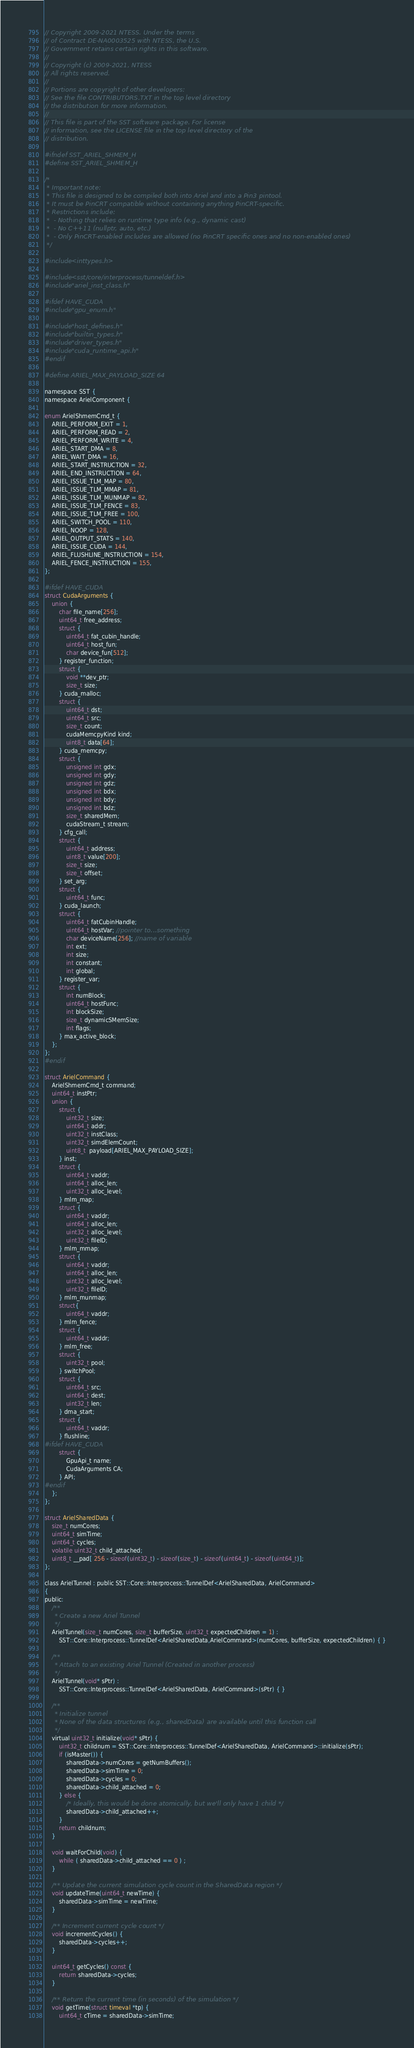<code> <loc_0><loc_0><loc_500><loc_500><_C_>// Copyright 2009-2021 NTESS. Under the terms
// of Contract DE-NA0003525 with NTESS, the U.S.
// Government retains certain rights in this software.
//
// Copyright (c) 2009-2021, NTESS
// All rights reserved.
//
// Portions are copyright of other developers:
// See the file CONTRIBUTORS.TXT in the top level directory
// the distribution for more information.
//
// This file is part of the SST software package. For license
// information, see the LICENSE file in the top level directory of the
// distribution.

#ifndef SST_ARIEL_SHMEM_H
#define SST_ARIEL_SHMEM_H

/*
 * Important note:
 * This file is designed to be compiled both into Ariel and into a Pin3 pintool.
 * It must be PinCRT compatible without containing anything PinCRT-specific.
 * Restrictions include:
 *  - Nothing that relies on runtime type info (e.g., dynamic cast)
 *  - No C++11 (nullptr, auto, etc.)
 *  - Only PinCRT-enabled includes are allowed (no PinCRT specific ones and no non-enabled ones)
 */

#include <inttypes.h>

#include <sst/core/interprocess/tunneldef.h>
#include "ariel_inst_class.h"

#ifdef HAVE_CUDA
#include "gpu_enum.h"

#include "host_defines.h"
#include "builtin_types.h"
#include "driver_types.h"
#include "cuda_runtime_api.h"
#endif

#define ARIEL_MAX_PAYLOAD_SIZE 64

namespace SST {
namespace ArielComponent {

enum ArielShmemCmd_t {
    ARIEL_PERFORM_EXIT = 1,
    ARIEL_PERFORM_READ = 2,
    ARIEL_PERFORM_WRITE = 4,
    ARIEL_START_DMA = 8,
    ARIEL_WAIT_DMA = 16,
    ARIEL_START_INSTRUCTION = 32,
    ARIEL_END_INSTRUCTION = 64,
    ARIEL_ISSUE_TLM_MAP = 80,
    ARIEL_ISSUE_TLM_MMAP = 81,
    ARIEL_ISSUE_TLM_MUNMAP = 82,
    ARIEL_ISSUE_TLM_FENCE = 83,
    ARIEL_ISSUE_TLM_FREE = 100,
    ARIEL_SWITCH_POOL = 110,
    ARIEL_NOOP = 128,
    ARIEL_OUTPUT_STATS = 140,
    ARIEL_ISSUE_CUDA = 144,
    ARIEL_FLUSHLINE_INSTRUCTION = 154,
    ARIEL_FENCE_INSTRUCTION = 155,
};

#ifdef HAVE_CUDA
struct CudaArguments {
    union {
        char file_name[256];
        uint64_t free_address;
        struct {
            uint64_t fat_cubin_handle;
            uint64_t host_fun;
            char device_fun[512];
        } register_function;
        struct {
            void **dev_ptr;
            size_t size;
        } cuda_malloc;
        struct {
            uint64_t dst;
            uint64_t src;
            size_t count;
            cudaMemcpyKind kind;
            uint8_t data[64];
        } cuda_memcpy;
        struct {
            unsigned int gdx;
            unsigned int gdy;
            unsigned int gdz;
            unsigned int bdx;
            unsigned int bdy;
            unsigned int bdz;
            size_t sharedMem;
            cudaStream_t stream;
        } cfg_call;
        struct {
            uint64_t address;
            uint8_t value[200];
            size_t size;
            size_t offset;
        } set_arg;
        struct {
            uint64_t func;
        } cuda_launch;
        struct {
            uint64_t fatCubinHandle;
            uint64_t hostVar; //pointer to...something
            char deviceName[256]; //name of variable
            int ext;
            int size;
            int constant;
            int global;
        } register_var;
        struct {
            int numBlock;
            uint64_t hostFunc;
            int blockSize;
            size_t dynamicSMemSize;
            int flags;
        } max_active_block;
    };
};
#endif

struct ArielCommand {
    ArielShmemCmd_t command;
    uint64_t instPtr;
    union {
        struct {
            uint32_t size;
            uint64_t addr;
            uint32_t instClass;
            uint32_t simdElemCount;
            uint8_t  payload[ARIEL_MAX_PAYLOAD_SIZE];
        } inst;
        struct {
            uint64_t vaddr;
            uint64_t alloc_len;
            uint32_t alloc_level;
        } mlm_map;
        struct {
            uint64_t vaddr;
            uint64_t alloc_len;
            uint32_t alloc_level;
            uint32_t fileID;
        } mlm_mmap;
        struct {
            uint64_t vaddr;
            uint64_t alloc_len;
            uint32_t alloc_level;
            uint32_t fileID;
        } mlm_munmap;
        struct{
            uint64_t vaddr;
        } mlm_fence;
        struct {
            uint64_t vaddr;
        } mlm_free;
        struct {
            uint32_t pool;
        } switchPool;
        struct {
            uint64_t src;
            uint64_t dest;
            uint32_t len;
        } dma_start;
        struct {
            uint64_t vaddr;
        } flushline;
#ifdef HAVE_CUDA
        struct {
            GpuApi_t name;
            CudaArguments CA;
        } API;
#endif
    };
};

struct ArielSharedData {
    size_t numCores;
    uint64_t simTime;
    uint64_t cycles;
    volatile uint32_t child_attached;
    uint8_t __pad[ 256 - sizeof(uint32_t) - sizeof(size_t) - sizeof(uint64_t) - sizeof(uint64_t)];
};

class ArielTunnel : public SST::Core::Interprocess::TunnelDef<ArielSharedData, ArielCommand>
{
public:
    /**
     * Create a new Ariel Tunnel
     */
    ArielTunnel(size_t numCores, size_t bufferSize, uint32_t expectedChildren = 1) :
        SST::Core::Interprocess::TunnelDef<ArielSharedData,ArielCommand>(numCores, bufferSize, expectedChildren) { }

    /**
     * Attach to an existing Ariel Tunnel (Created in another process)
     */
    ArielTunnel(void* sPtr) :
        SST::Core::Interprocess::TunnelDef<ArielSharedData, ArielCommand>(sPtr) { }

    /**
     * Initialize tunnel
     * None of the data structures (e.g., sharedData) are available until this function call
     */
    virtual uint32_t initialize(void* sPtr) {
        uint32_t childnum = SST::Core::Interprocess::TunnelDef<ArielSharedData, ArielCommand>::initialize(sPtr);
        if (isMaster()) {
            sharedData->numCores = getNumBuffers();
            sharedData->simTime = 0;
            sharedData->cycles = 0;
            sharedData->child_attached = 0;
        } else {
            /* Ideally, this would be done atomically, but we'll only have 1 child */
            sharedData->child_attached++;
        }
        return childnum;
    }

    void waitForChild(void) {
        while ( sharedData->child_attached == 0 ) ;
    }

    /** Update the current simulation cycle count in the SharedData region */
    void updateTime(uint64_t newTime) {
        sharedData->simTime = newTime;
    }

    /** Increment current cycle count */
    void incrementCycles() {
        sharedData->cycles++;
    }

    uint64_t getCycles() const {
        return sharedData->cycles;
    }

    /** Return the current time (in seconds) of the simulation */
    void getTime(struct timeval *tp) {
        uint64_t cTime = sharedData->simTime;</code> 